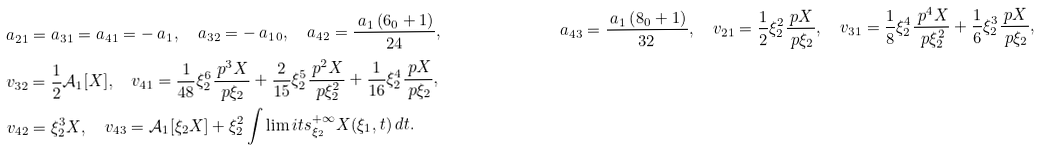Convert formula to latex. <formula><loc_0><loc_0><loc_500><loc_500>{ } & a _ { 2 1 } = a _ { 3 1 } = a _ { 4 1 } = - \ a _ { 1 } , \quad a _ { 3 2 } = - \ a _ { 1 } \L _ { 0 } , \quad a _ { 4 2 } = \frac { \ a _ { 1 } \left ( 6 \L _ { 0 } + 1 \right ) } { 2 4 } , & a _ { 4 3 } = \frac { \ a _ { 1 } \left ( 8 \L _ { 0 } + 1 \right ) } { 3 2 } , \quad v _ { 2 1 } = \frac { 1 } { 2 } \xi _ { 2 } ^ { 2 } \frac { \ p X } { \ p \xi _ { 2 } } , \quad v _ { 3 1 } = \frac { 1 } { 8 } \xi _ { 2 } ^ { 4 } \frac { \ p ^ { 4 } X } { \ p \xi _ { 2 } ^ { 2 } } + \frac { 1 } { 6 } \xi _ { 2 } ^ { 3 } \frac { \ p X } { \ p \xi _ { 2 } } , \\ & v _ { 3 2 } = \frac { 1 } { 2 } \mathcal { A } _ { 1 } [ X ] , \quad v _ { 4 1 } = \frac { 1 } { 4 8 } \xi _ { 2 } ^ { 6 } \frac { \ p ^ { 3 } X } { \ p \xi _ { 2 } } + \frac { 2 } { 1 5 } \xi _ { 2 } ^ { 5 } \frac { \ p ^ { 2 } X } { \ p \xi _ { 2 } ^ { 2 } } + \frac { 1 } { 1 6 } \xi _ { 2 } ^ { 4 } \frac { \ p X } { \ p \xi _ { 2 } } , \\ & v _ { 4 2 } = \xi _ { 2 } ^ { 3 } X , \quad v _ { 4 3 } = \mathcal { A } _ { 1 } [ \xi _ { 2 } X ] + \xi _ { 2 } ^ { 2 } \int \lim i t s _ { \xi _ { 2 } } ^ { + \infty } X ( \xi _ { 1 } , t ) \, d t .</formula> 